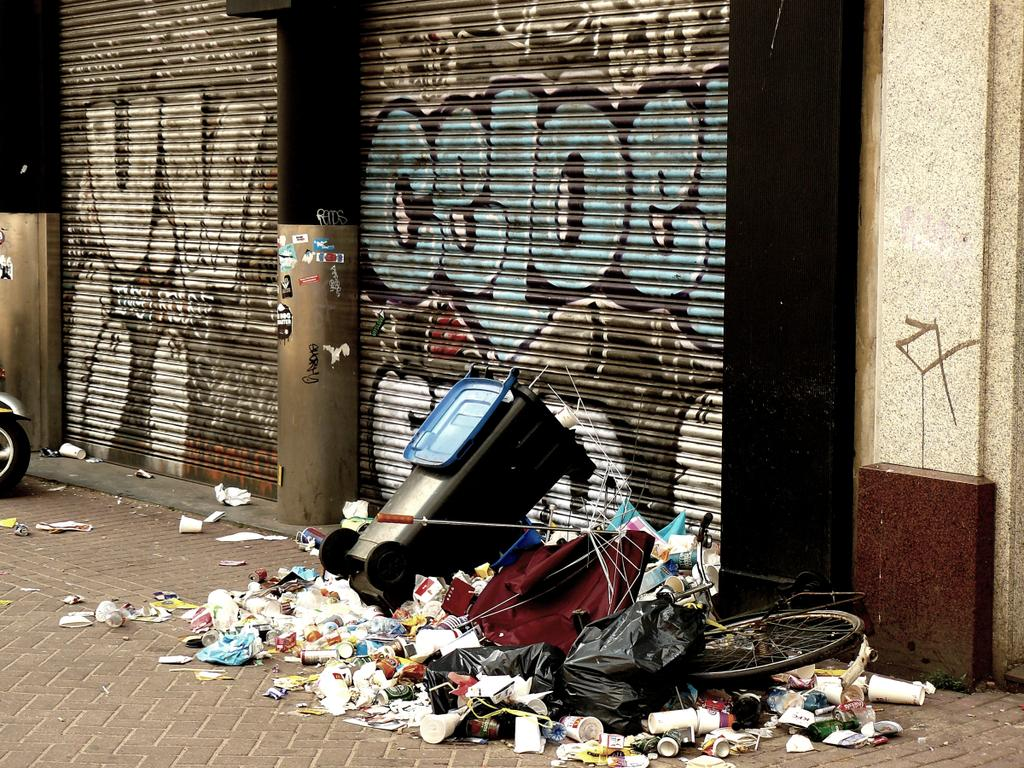Provide a one-sentence caption for the provided image. A heap of trash and a trash can with a graffiti saying celoe at the back. 